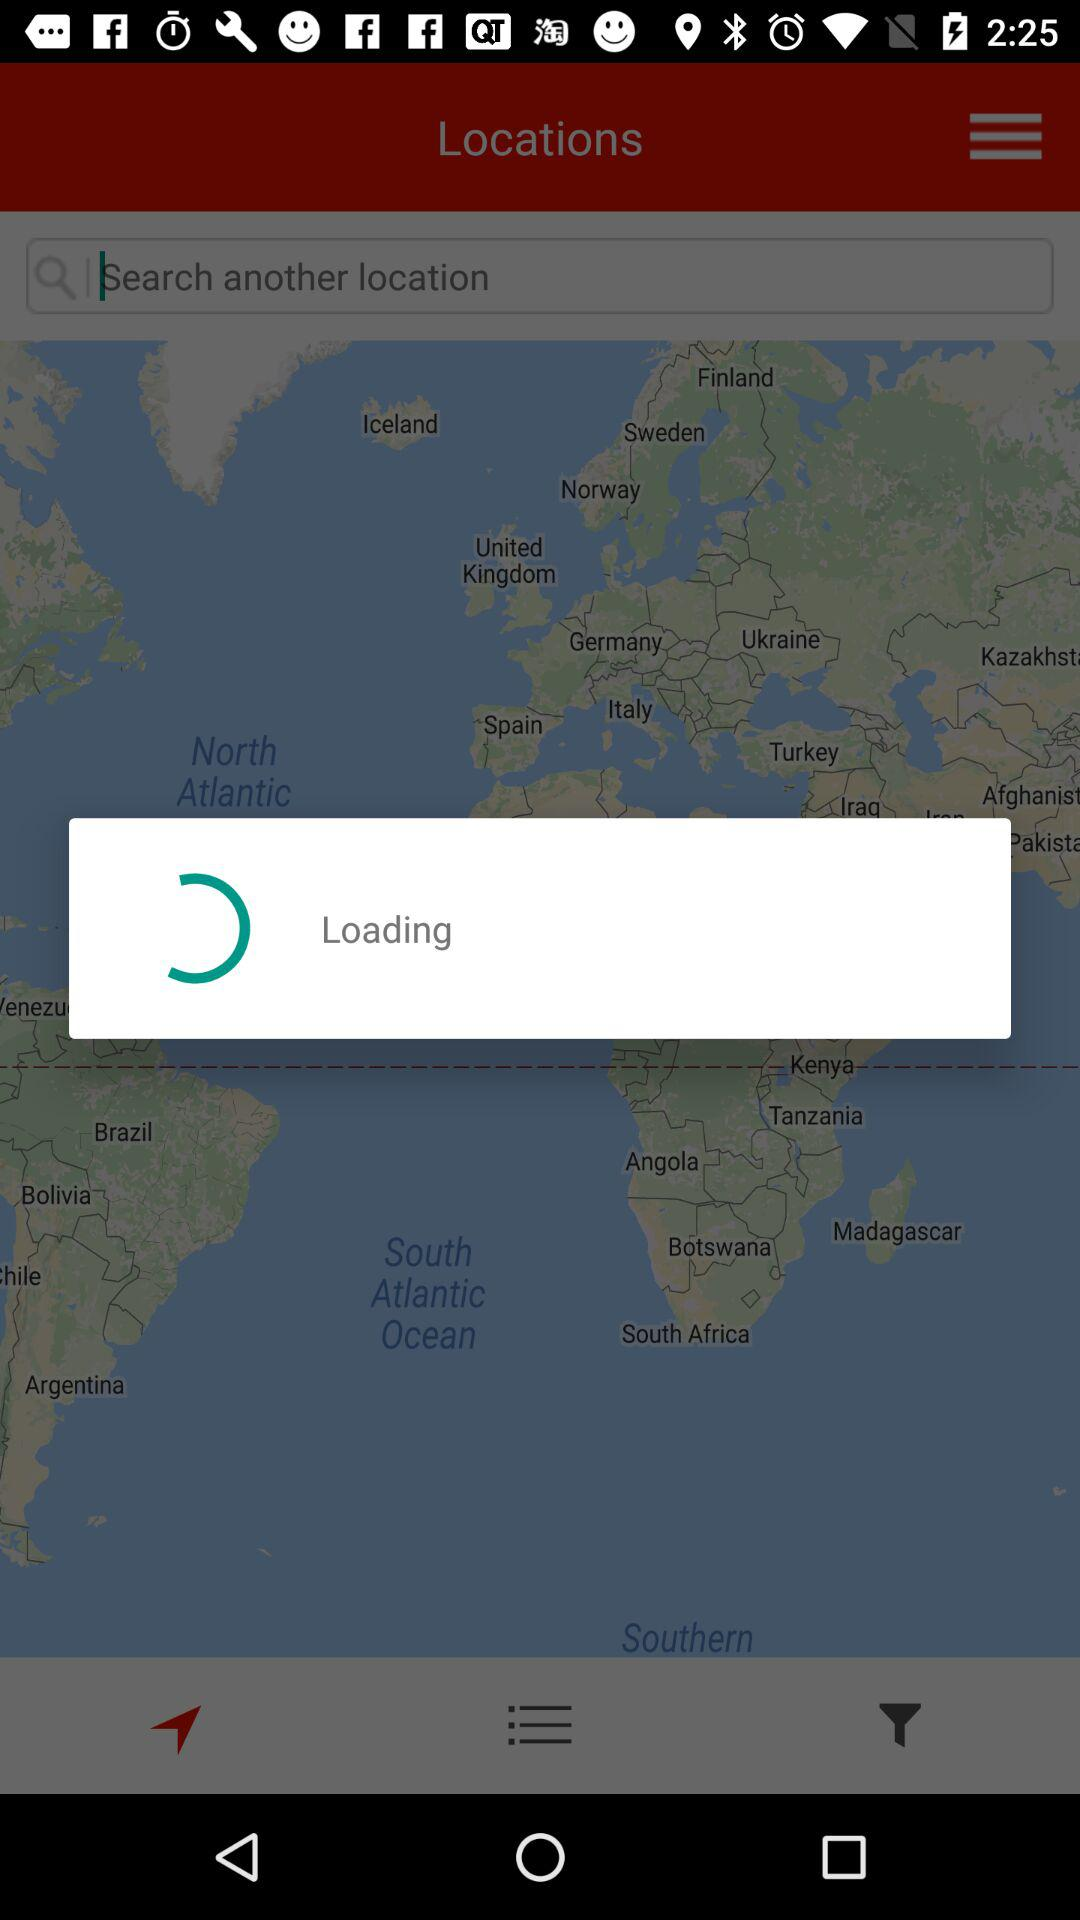What is the status of "Remember me"? The status is "off". 